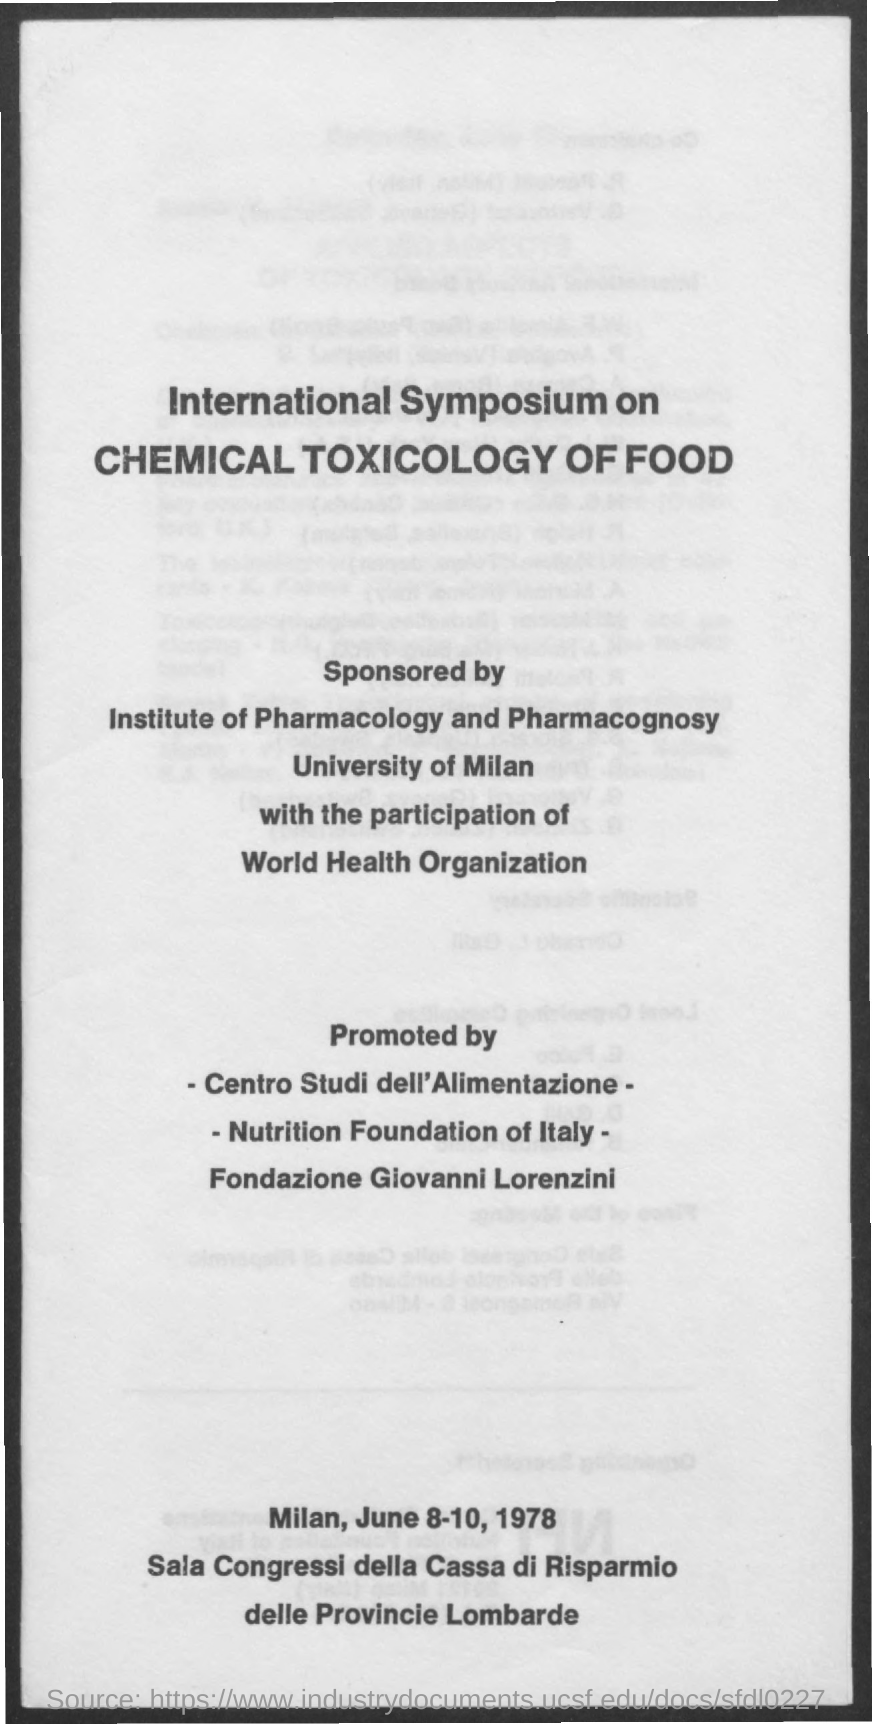What is international symposium on?
Give a very brief answer. Chemical toxicology of food. Who sponsored international symposium on chemical toxicology of food?
Ensure brevity in your answer.  Institute of pharmacology and pharmacognosy. 